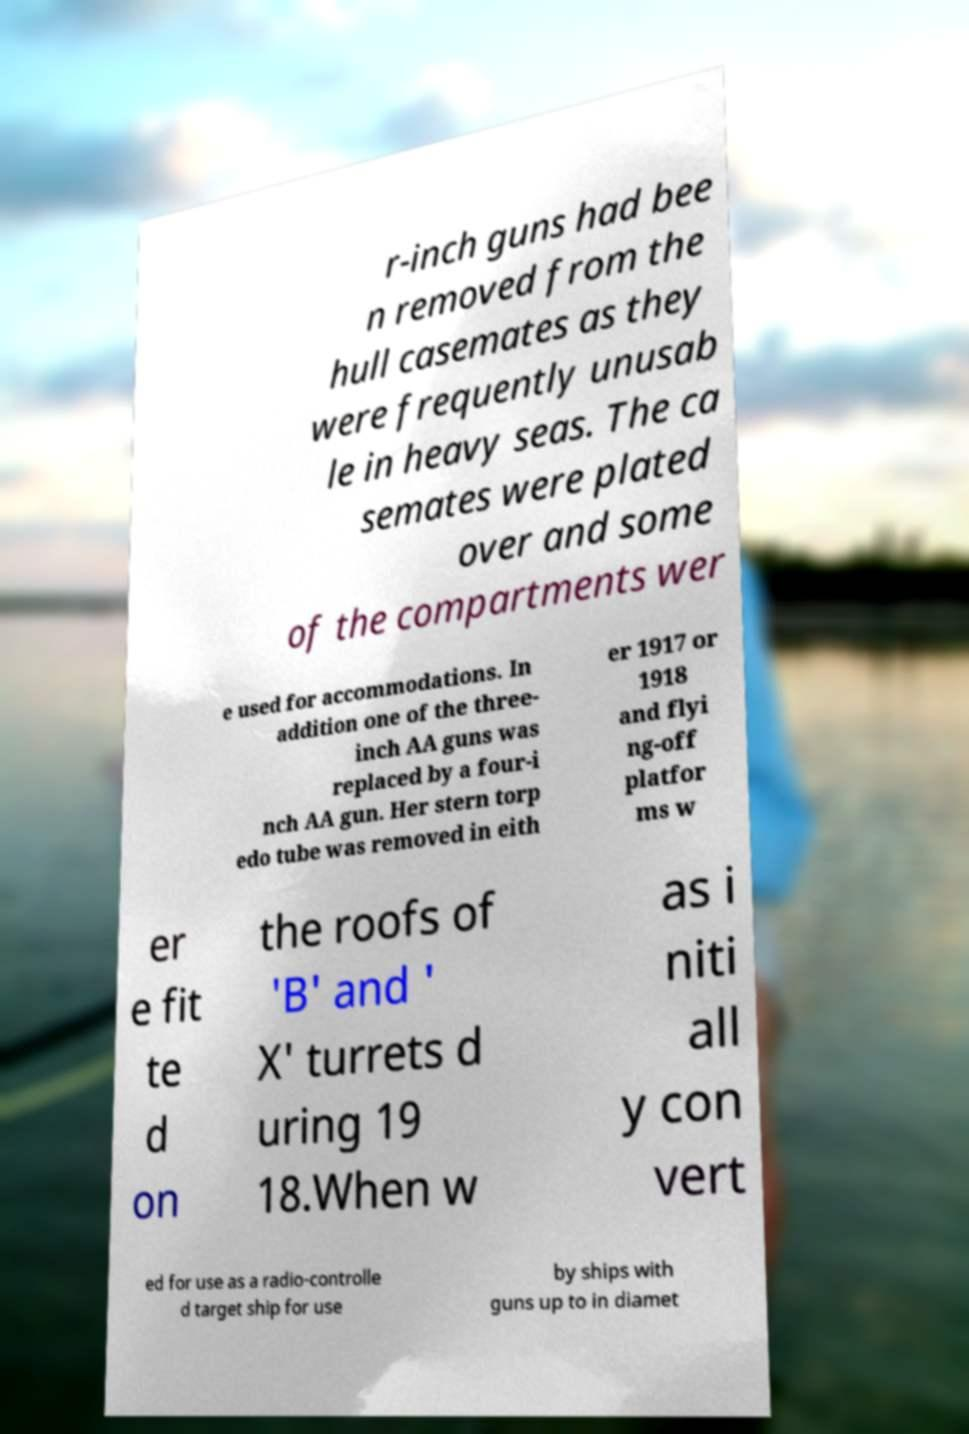There's text embedded in this image that I need extracted. Can you transcribe it verbatim? r-inch guns had bee n removed from the hull casemates as they were frequently unusab le in heavy seas. The ca semates were plated over and some of the compartments wer e used for accommodations. In addition one of the three- inch AA guns was replaced by a four-i nch AA gun. Her stern torp edo tube was removed in eith er 1917 or 1918 and flyi ng-off platfor ms w er e fit te d on the roofs of 'B' and ' X' turrets d uring 19 18.When w as i niti all y con vert ed for use as a radio-controlle d target ship for use by ships with guns up to in diamet 